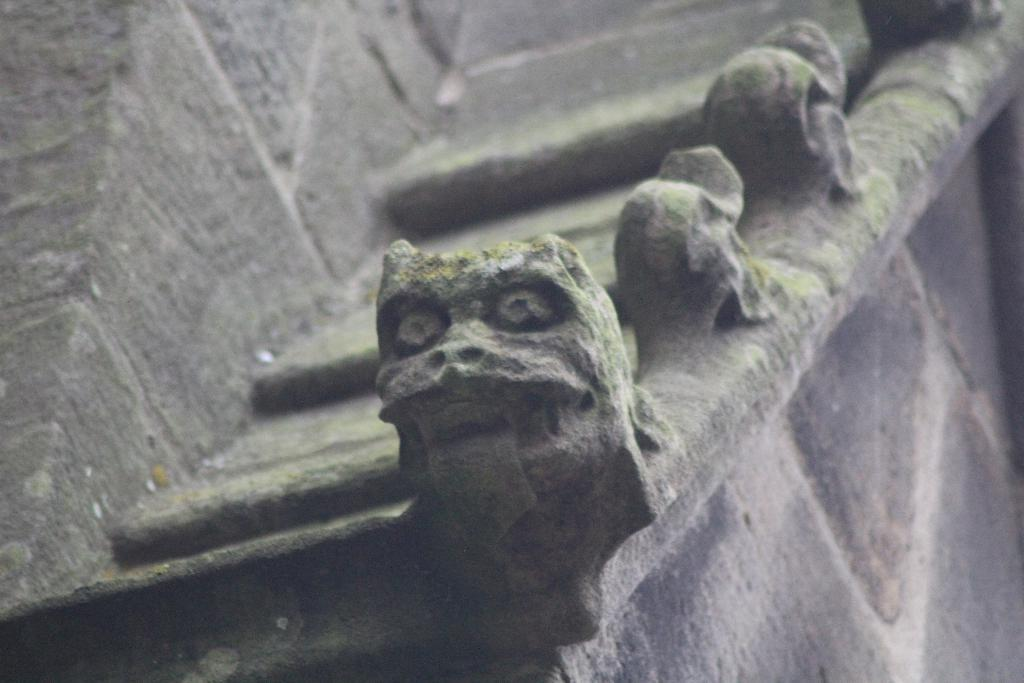What is depicted on the wall in the image? There is carving on a wall in the image. What type of fuel is being used by the carving in the image? There is no fuel involved in the carving; it is a static image on the wall. 